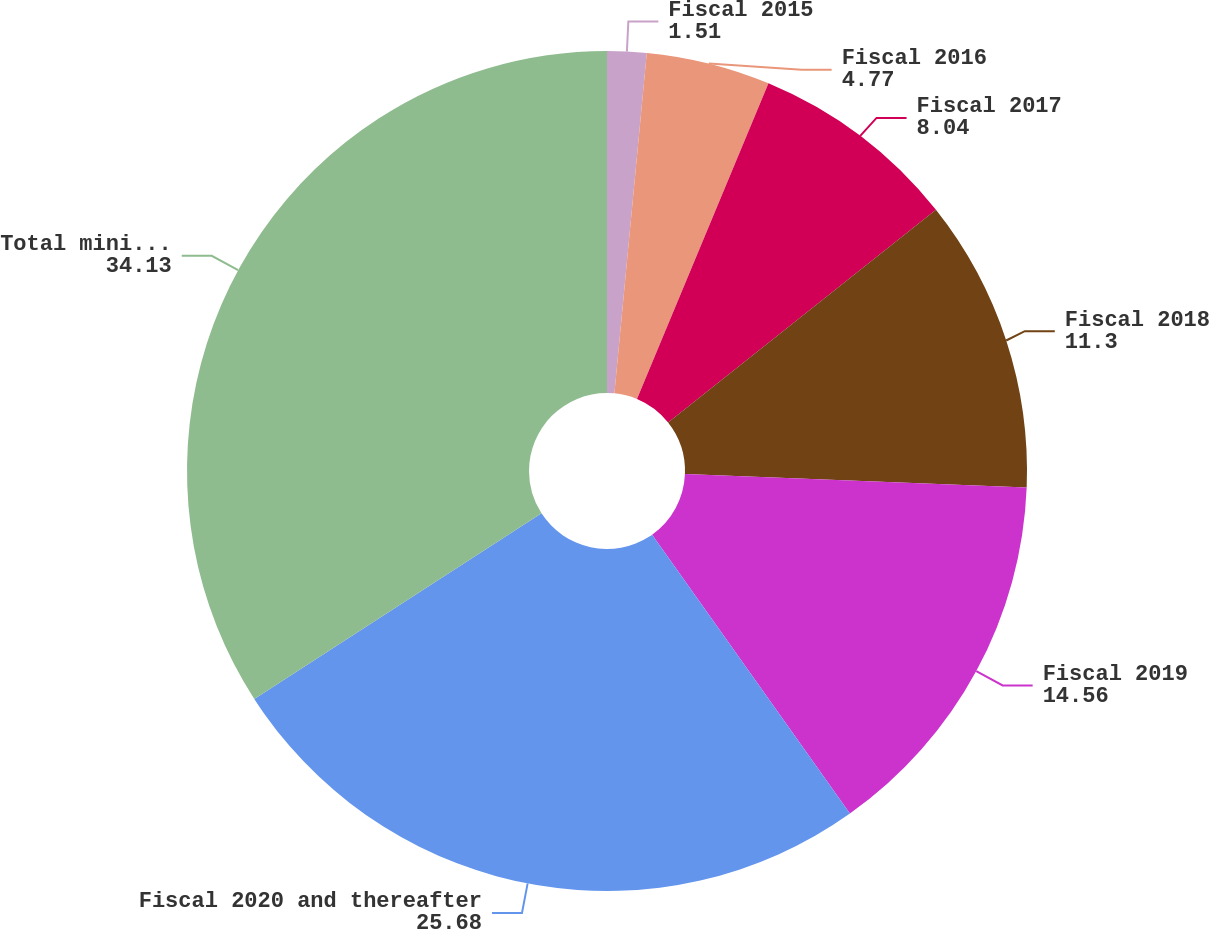Convert chart to OTSL. <chart><loc_0><loc_0><loc_500><loc_500><pie_chart><fcel>Fiscal 2015<fcel>Fiscal 2016<fcel>Fiscal 2017<fcel>Fiscal 2018<fcel>Fiscal 2019<fcel>Fiscal 2020 and thereafter<fcel>Total minimum lease payments<nl><fcel>1.51%<fcel>4.77%<fcel>8.04%<fcel>11.3%<fcel>14.56%<fcel>25.68%<fcel>34.13%<nl></chart> 